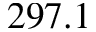<formula> <loc_0><loc_0><loc_500><loc_500>2 9 7 . 1</formula> 